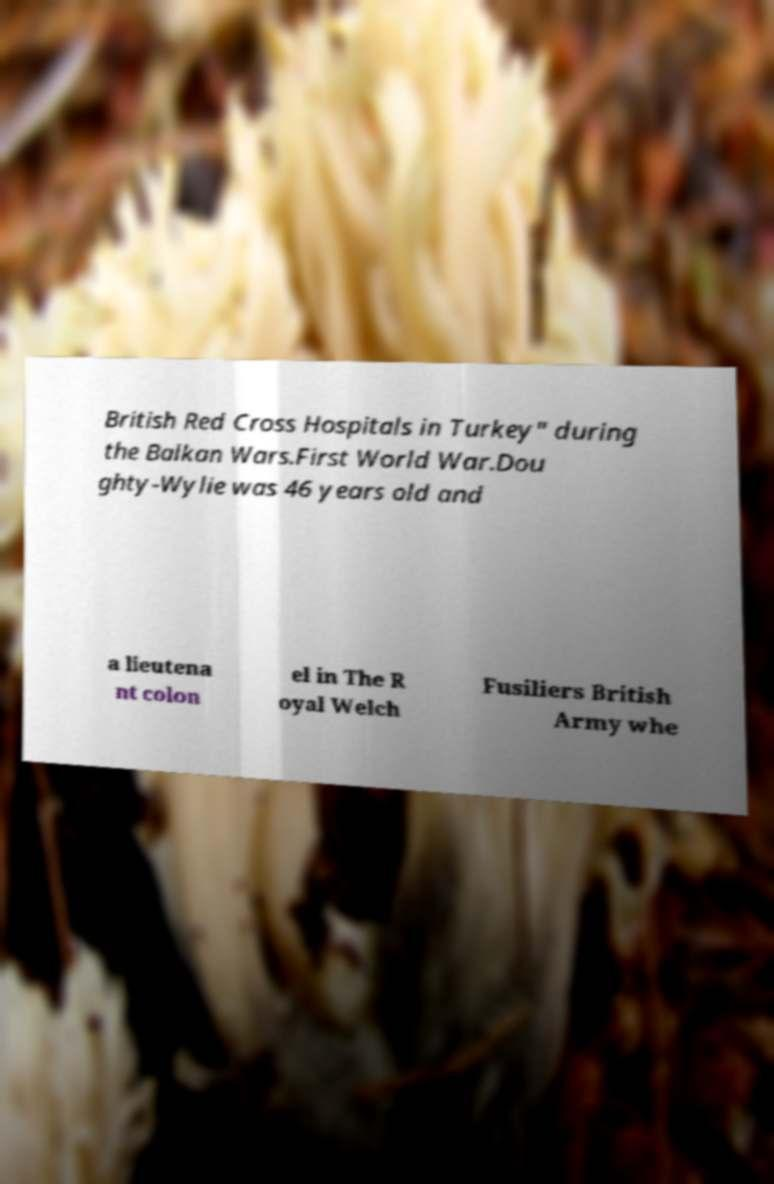What messages or text are displayed in this image? I need them in a readable, typed format. British Red Cross Hospitals in Turkey" during the Balkan Wars.First World War.Dou ghty-Wylie was 46 years old and a lieutena nt colon el in The R oyal Welch Fusiliers British Army whe 